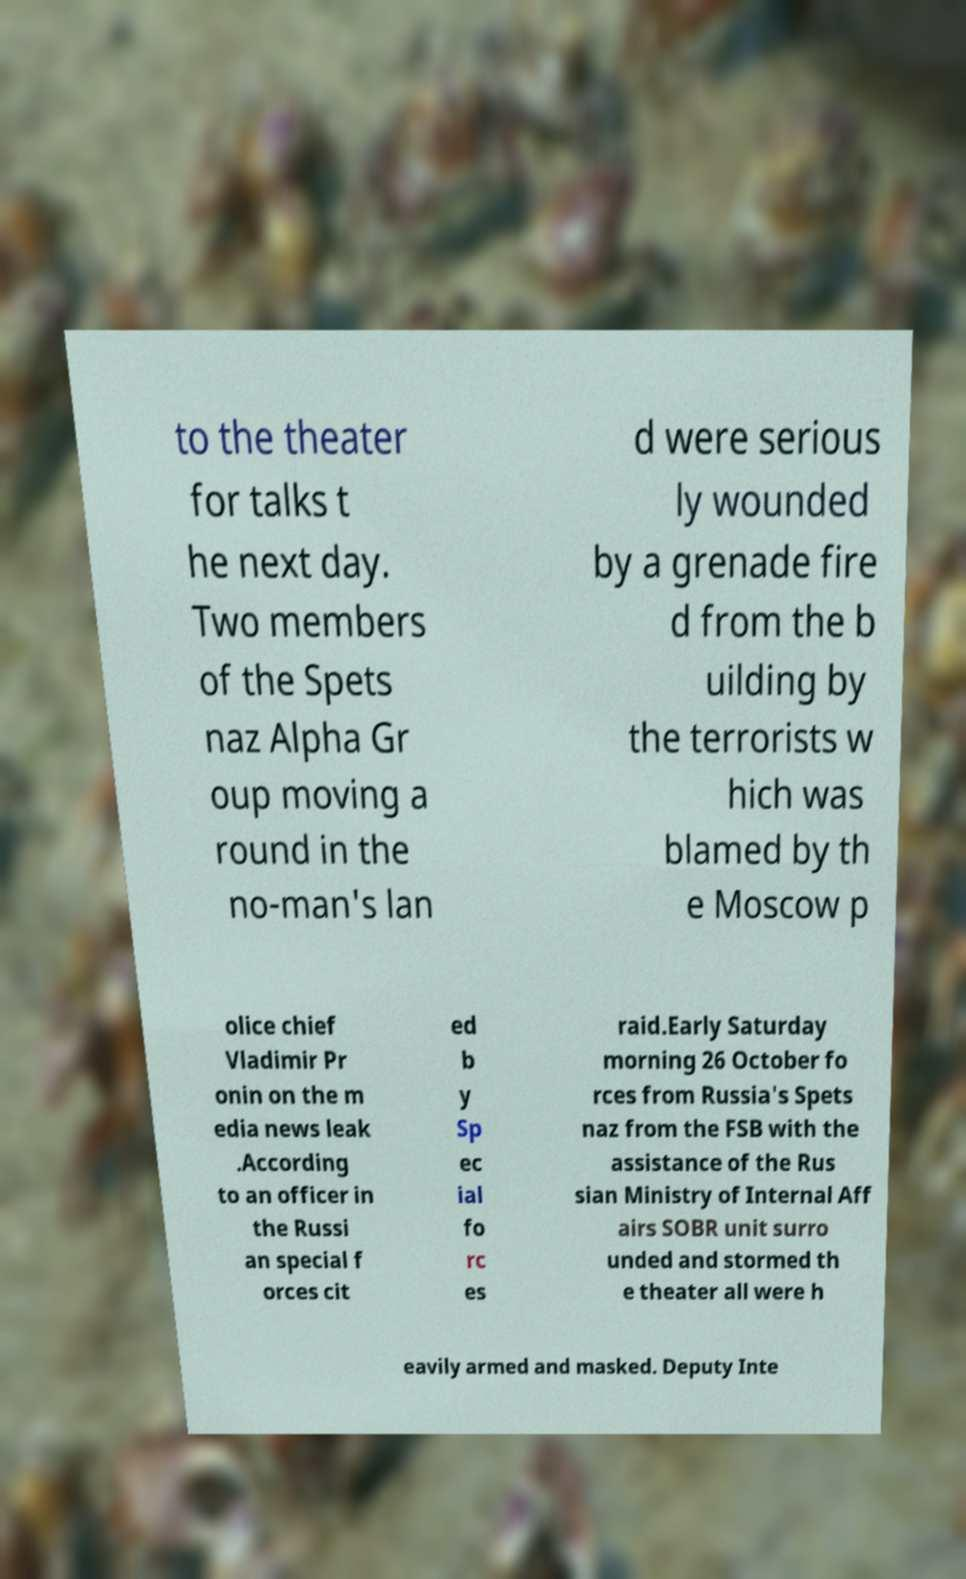Could you assist in decoding the text presented in this image and type it out clearly? to the theater for talks t he next day. Two members of the Spets naz Alpha Gr oup moving a round in the no-man's lan d were serious ly wounded by a grenade fire d from the b uilding by the terrorists w hich was blamed by th e Moscow p olice chief Vladimir Pr onin on the m edia news leak .According to an officer in the Russi an special f orces cit ed b y Sp ec ial fo rc es raid.Early Saturday morning 26 October fo rces from Russia's Spets naz from the FSB with the assistance of the Rus sian Ministry of Internal Aff airs SOBR unit surro unded and stormed th e theater all were h eavily armed and masked. Deputy Inte 